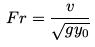<formula> <loc_0><loc_0><loc_500><loc_500>F r = \frac { v } { \sqrt { g y _ { 0 } } }</formula> 